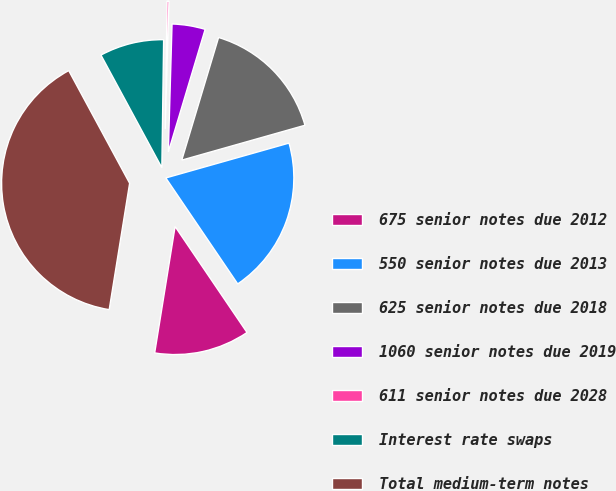Convert chart to OTSL. <chart><loc_0><loc_0><loc_500><loc_500><pie_chart><fcel>675 senior notes due 2012<fcel>550 senior notes due 2013<fcel>625 senior notes due 2018<fcel>1060 senior notes due 2019<fcel>611 senior notes due 2028<fcel>Interest rate swaps<fcel>Total medium-term notes<nl><fcel>12.04%<fcel>19.9%<fcel>15.97%<fcel>4.18%<fcel>0.24%<fcel>8.11%<fcel>39.56%<nl></chart> 